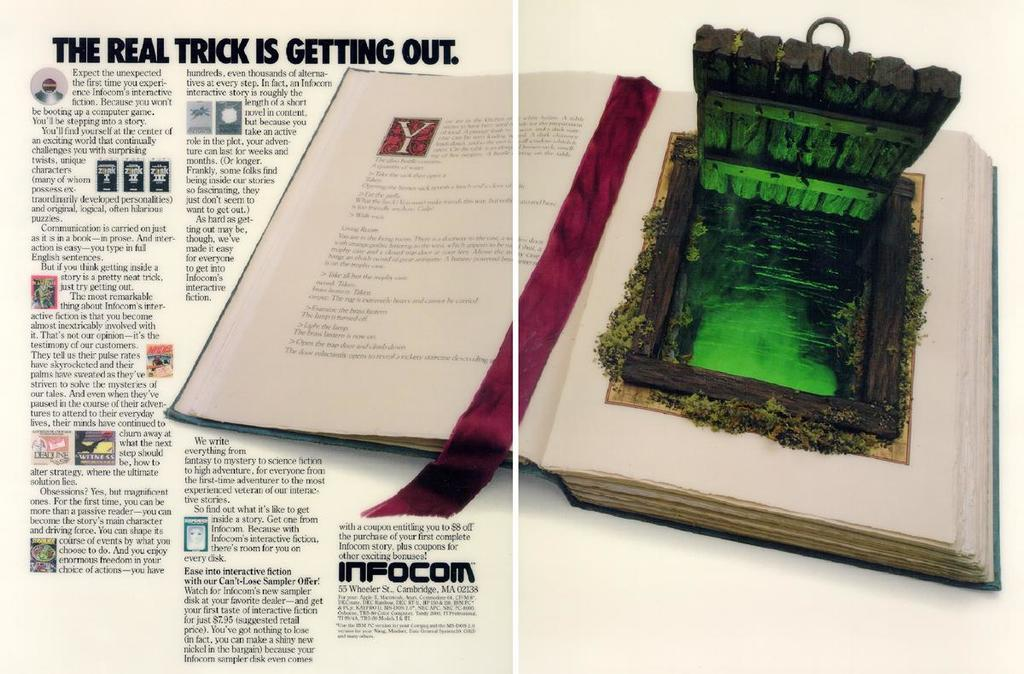<image>
Relay a brief, clear account of the picture shown. The book here is from the site called Infocom 